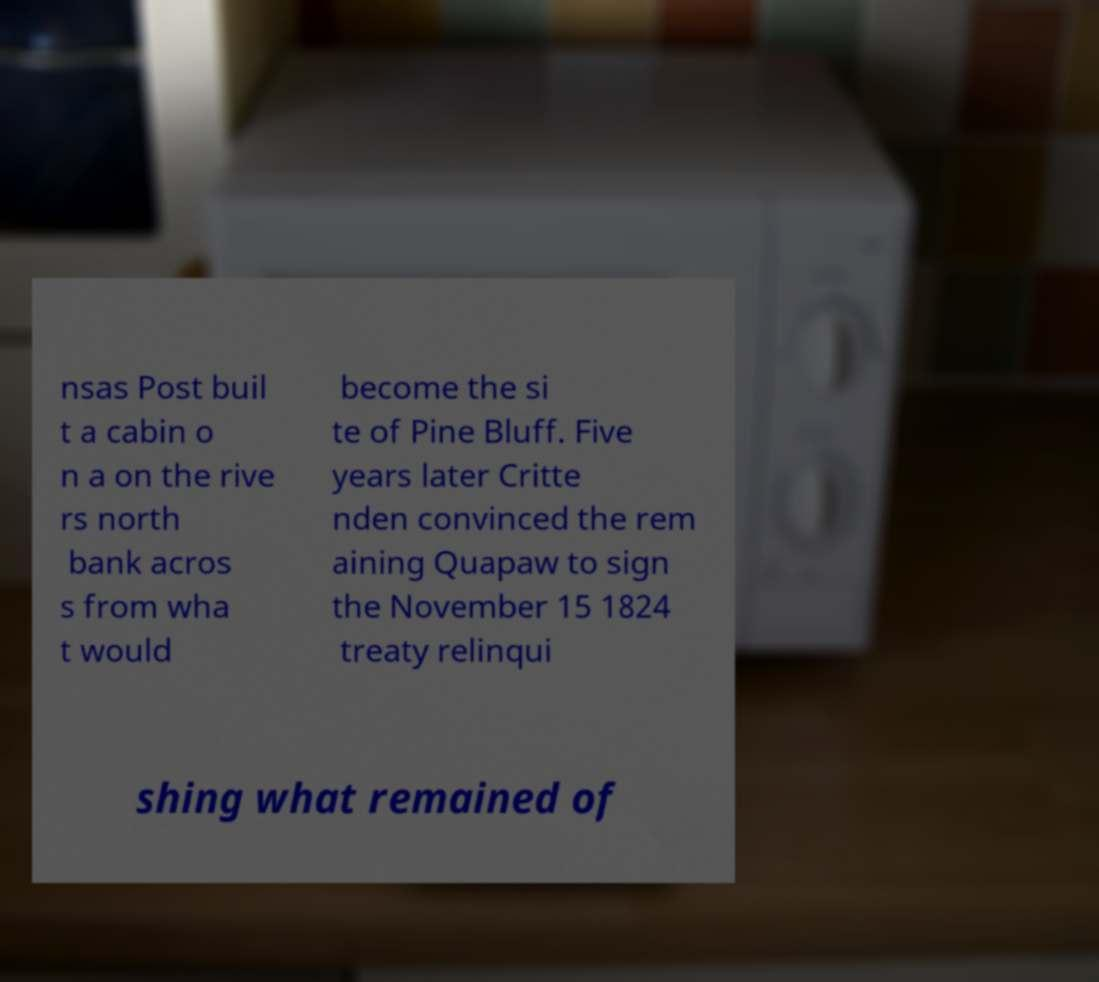Could you extract and type out the text from this image? nsas Post buil t a cabin o n a on the rive rs north bank acros s from wha t would become the si te of Pine Bluff. Five years later Critte nden convinced the rem aining Quapaw to sign the November 15 1824 treaty relinqui shing what remained of 